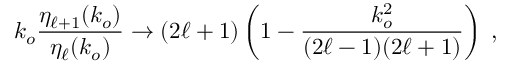<formula> <loc_0><loc_0><loc_500><loc_500>k _ { o } \frac { \eta _ { \ell + 1 } ( k _ { o } ) } { \eta _ { \ell } ( k _ { o } ) } \rightarrow ( 2 \ell + 1 ) \left ( 1 - \frac { k _ { o } ^ { 2 } } { ( 2 \ell - 1 ) ( 2 \ell + 1 ) } \right ) \, ,</formula> 